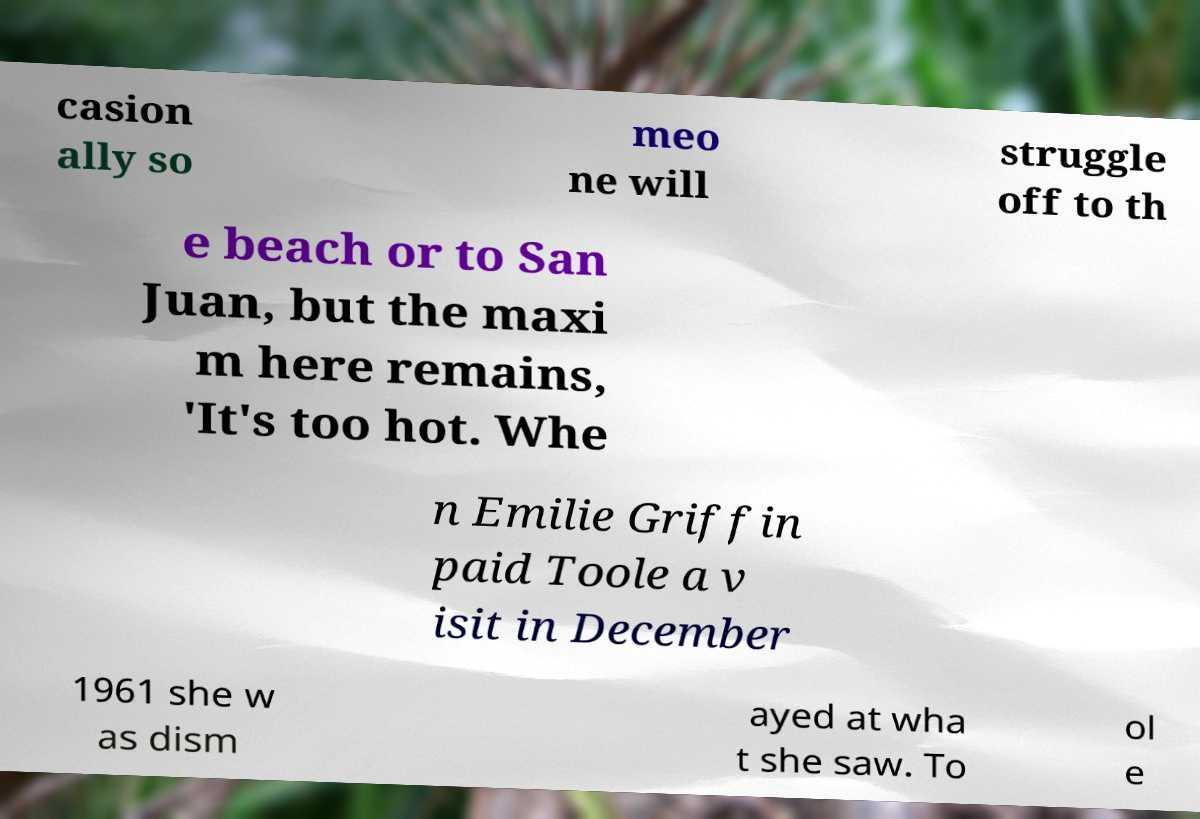I need the written content from this picture converted into text. Can you do that? casion ally so meo ne will struggle off to th e beach or to San Juan, but the maxi m here remains, 'It's too hot. Whe n Emilie Griffin paid Toole a v isit in December 1961 she w as dism ayed at wha t she saw. To ol e 